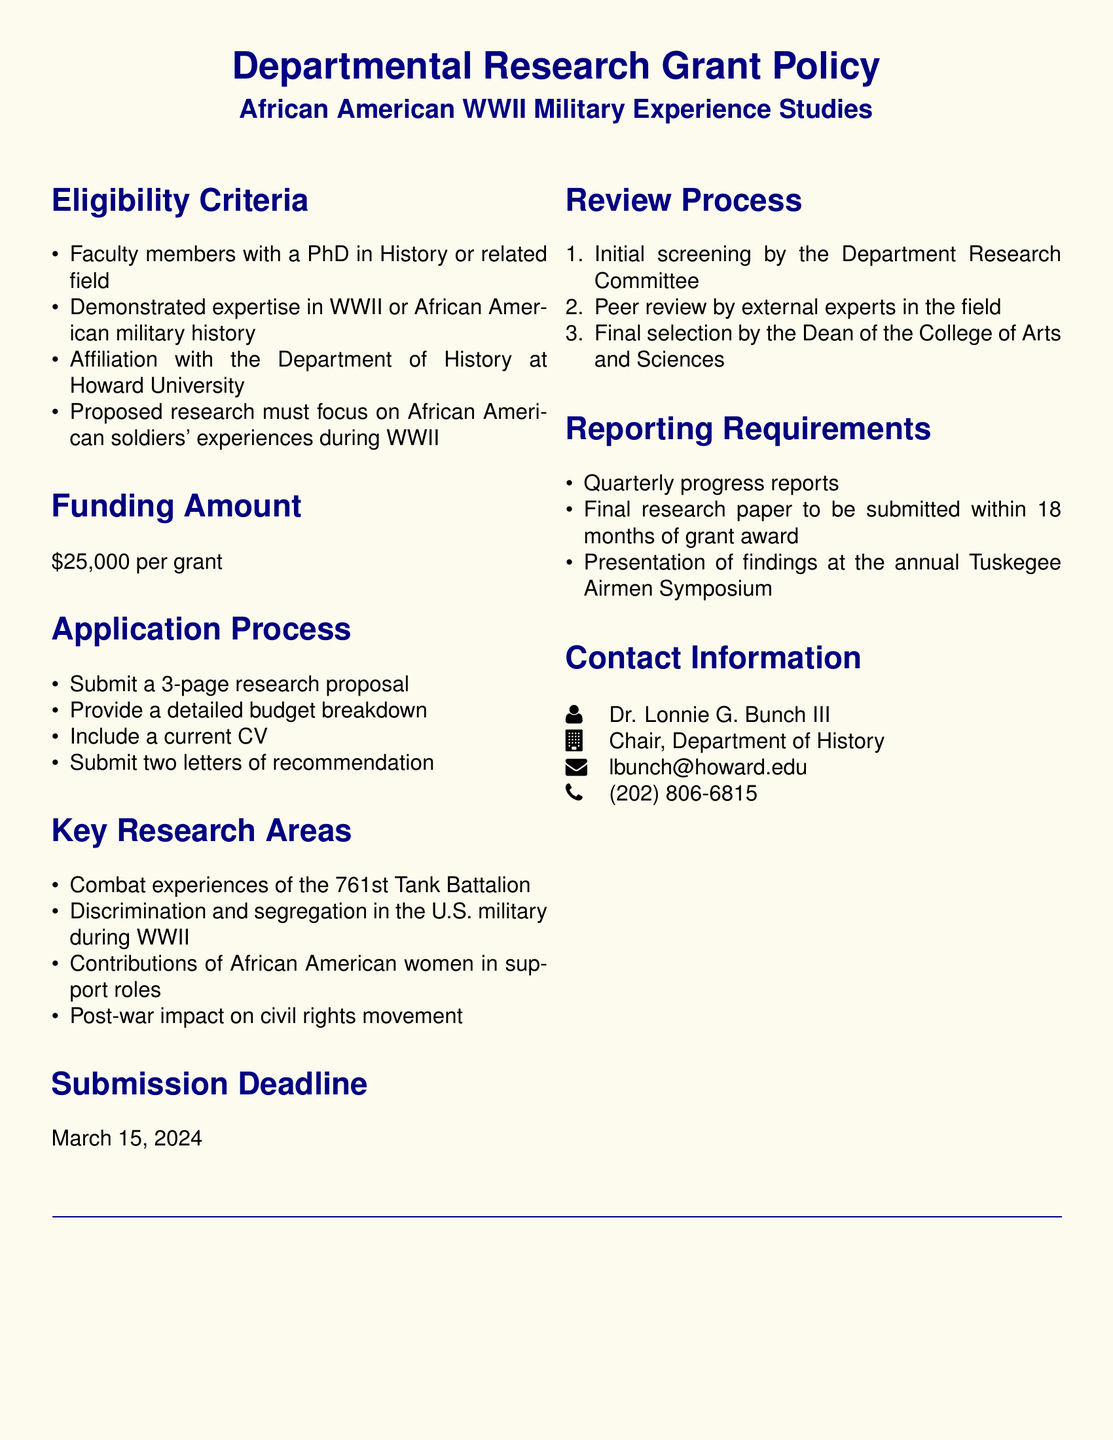What is the funding amount for each grant? The funding amount is explicitly stated in the document under the 'Funding Amount' section.
Answer: $25,000 Who is the contact person for the grant applications? The contact person's name is provided in the 'Contact Information' section.
Answer: Dr. Lonnie G. Bunch III What is the submission deadline for the application? The submission deadline is noted towards the end of the document, providing a clear date for till which applications can be submitted.
Answer: March 15, 2024 What is required to be included in the application process? The application process section lists items that applicants need to submit, which shows the required documents.
Answer: 3-page research proposal, detailed budget breakdown, current CV, two letters of recommendation What are the key research areas mentioned for the grant? The key research areas are listed under a specific section and reflect the focus of the grants.
Answer: Combat experiences of the 761st Tank Battalion, Discrimination and segregation in the U.S. military during WWII, Contributions of African American women in support roles, Post-war impact on civil rights movement How long do recipients have to submit their final research paper after receiving the grant? The duration for submitting the final paper is specified under the 'Reporting Requirements' section.
Answer: 18 months What types of individuals are eligible to apply for the grant? The 'Eligibility Criteria' section outlines the requirements for prospective applicants.
Answer: Faculty members with a PhD in History or related field What is the order of the review process described in the document? The review process is detailed in a numbered list, indicating the steps involved.
Answer: Initial screening by the Department Research Committee, Peer review by external experts in the field, Final selection by the Dean of the College of Arts and Sciences 